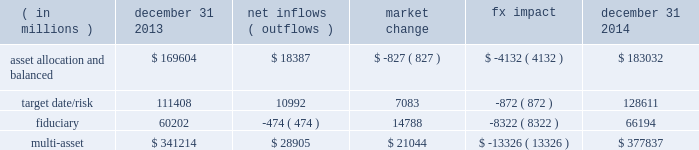Long-term product offerings include active and index strategies .
Our active strategies seek to earn attractive returns in excess of a market benchmark or performance hurdle while maintaining an appropriate risk profile .
We offer two types of active strategies : those that rely primarily on fundamental research and those that utilize primarily quantitative models to drive portfolio construction .
In contrast , index strategies seek to closely track the returns of a corresponding index , generally by investing in substantially the same underlying securities within the index or in a subset of those securities selected to approximate a similar risk and return profile of the index .
Index strategies include both our non-etf index products and ishares etfs .
Althoughmany clients use both active and index strategies , the application of these strategies may differ .
For example , clients may use index products to gain exposure to a market or asset class .
In addition , institutional non-etf index assignments tend to be very large ( multi-billion dollars ) and typically reflect low fee rates .
This has the potential to exaggerate the significance of net flows in institutional index products on blackrock 2019s revenues and earnings .
Equity year-end 2014 equity aum of $ 2.451 trillion increased by $ 133.4 billion , or 6% ( 6 % ) , from the end of 2013 due to net new business of $ 52.4 billion and net market appreciation and foreign exchange movements of $ 81.0 billion .
Net inflows were driven by $ 59.6 billion and $ 17.7 billion into ishares and non-etf index accounts , respectively .
Index inflows were offset by active net outflows of $ 24.9 billion , with outflows of $ 18.0 billion and $ 6.9 billion from fundamental and scientific active equity products , respectively .
Blackrock 2019s effective fee rates fluctuate due to changes in aummix .
Approximately half of blackrock 2019s equity aum is tied to international markets , including emerging markets , which tend to have higher fee rates than similar u.s .
Equity strategies .
Accordingly , fluctuations in international equity markets , which do not consistently move in tandemwith u.s .
Markets , may have a greater impact on blackrock 2019s effective equity fee rates and revenues .
Fixed income fixed income aum ended 2014 at $ 1.394 trillion , increasing $ 151.5 billion , or 12% ( 12 % ) , from december 31 , 2013 .
The increase in aum reflected $ 96.4 billion in net new business and $ 55.1 billion in net market appreciation and foreign exchange movements .
In 2014 , net new business was diversified across fixed income offerings , with strong flows into our unconstrained , total return and high yield products .
Flagship funds in these product areas include our unconstrained strategic income opportunities and fixed income global opportunities funds , with net inflows of $ 13.3 billion and $ 4.2 billion , respectively ; our total return fund with net inflows of $ 2.1 billion ; and our high yield bond fund with net inflows of $ 2.1 billion .
Fixed income net inflows were positive across investment styles , with ishares , non- etf index , and active net inflows of $ 40.0 billion , $ 28.7 billion and $ 27.7 billion , respectively .
Multi-asset class blackrock 2019s multi-asset class teammanages a variety of balanced funds and bespoke mandates for a diversified client base that leverages our broad investment expertise in global equities , currencies , bonds and commodities , and our extensive risk management capabilities .
Investment solutions might include a combination of long-only portfolios and alternative investments as well as tactical asset allocation overlays .
Component changes in multi-asset class aum for 2014 are presented below .
( in millions ) december 31 , 2013 net inflows ( outflows ) market change fx impact december 31 , 2014 .
Flows reflected ongoing institutional demand for our solutions-based advice with $ 15.1 billion , or 52% ( 52 % ) , of net inflows coming from institutional clients .
Defined contribution plans of institutional clients remained a significant driver of flows , and contributed $ 12.8 billion to institutional multi- asset class net new business in 2014 , primarily into target date and target risk product offerings .
Retail net inflows of $ 13.4 billion were driven by particular demand for our multi- asset income fund , which raised $ 6.3 billion in 2014 .
The company 2019s multi-asset strategies include the following : 2022 asset allocation and balanced products represented 48% ( 48 % ) of multi-asset class aum at year-end , with growth in aum driven by net new business of $ 18.4 billion .
These strategies combine equity , fixed income and alternative components for investors seeking a tailored solution relative to a specific benchmark and within a risk budget .
In certain cases , these strategies seek to minimize downside risk through diversification , derivatives strategies and tactical asset allocation decisions .
Flagship products in this category include our global allocation andmulti-asset income suites .
2022 target date and target risk products grew 10% ( 10 % ) organically in 2014 .
Institutional investors represented 90% ( 90 % ) of target date and target risk aum , with defined contribution plans accounting for over 80% ( 80 % ) of aum .
The remaining 10% ( 10 % ) of target date and target risk aum consisted of retail client investments .
Flows were driven by defined contribution investments in our lifepath and lifepath retirement income ae offerings .
Lifepath products utilize a proprietary asset allocation model that seeks to balance risk and return over an investment horizon based on the investor 2019s expected retirement timing .
2022 fiduciary management services are complex mandates in which pension plan sponsors or endowments and foundations retain blackrock to assume responsibility for some or all aspects of planmanagement .
These customized services require strong partnership with the clients 2019 investment staff and trustees in order to tailor investment strategies to meet client-specific risk budgets and return objectives. .
In 2014 , what percent of the multi asset value was the value of of asset allocation and balanced? 
Computations: (183032 / 377837)
Answer: 0.48442. 